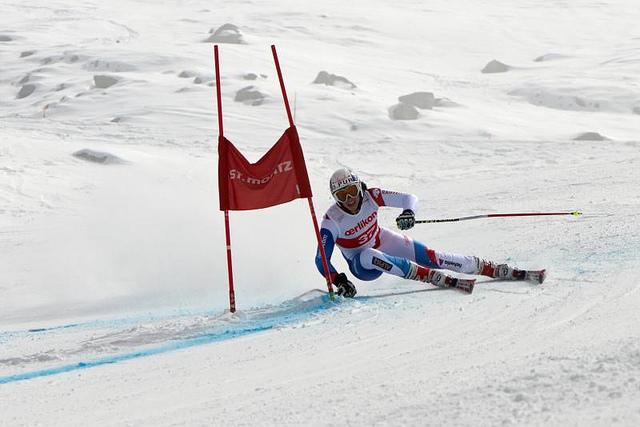What color is the flag?
Be succinct. Red. Is the skier going fast?
Quick response, please. Yes. Is this a competition?
Answer briefly. Yes. 